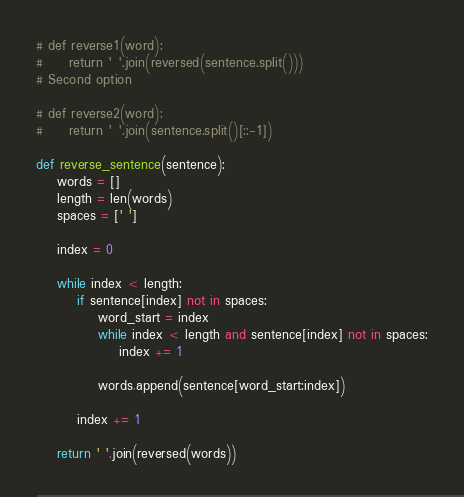Convert code to text. <code><loc_0><loc_0><loc_500><loc_500><_Python_># def reverse1(word):
#     return ' '.join(reversed(sentence.split())) 
# Second option

# def reverse2(word):
#     return ' '.join(sentence.split()[::-1])

def reverse_sentence(sentence):
    words = []
    length = len(words)
    spaces = [' ']
    
    index = 0
    
    while index < length:
        if sentence[index] not in spaces:
            word_start = index
            while index < length and sentence[index] not in spaces:
                index += 1
                
            words.append(sentence[word_start:index])
        
        index += 1
    
    return ' '.join(reversed(words))</code> 